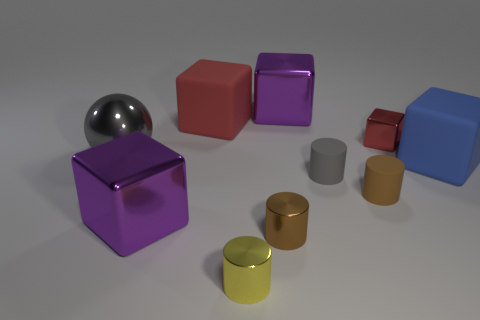What number of purple blocks have the same size as the yellow object?
Your response must be concise. 0. What is the shape of the large object that is the same color as the tiny metallic cube?
Make the answer very short. Cube. Is there a tiny red thing on the left side of the thing behind the red matte thing?
Offer a very short reply. No. How many objects are large purple metallic objects that are in front of the blue rubber thing or gray rubber cylinders?
Your answer should be very brief. 2. How many brown shiny cylinders are there?
Keep it short and to the point. 1. What shape is the small brown thing that is the same material as the big blue cube?
Provide a succinct answer. Cylinder. There is a matte block on the right side of the red block left of the tiny yellow metal thing; how big is it?
Offer a terse response. Large. How many things are either purple things in front of the metallic sphere or large cubes that are on the left side of the red matte block?
Provide a short and direct response. 1. Are there fewer red shiny objects than small green rubber spheres?
Your answer should be compact. No. How many objects are gray matte things or large metal objects?
Provide a succinct answer. 4. 